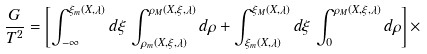<formula> <loc_0><loc_0><loc_500><loc_500>\frac { G } { T ^ { 2 } } = \left [ \int _ { - \infty } ^ { \xi _ { m } ( X , \lambda ) } d \xi \, \int _ { \rho _ { m } ( X , \xi , \lambda ) } ^ { \rho _ { M } ( X , \xi , \lambda ) } d \rho + \int _ { \xi _ { m } ( X , \lambda ) } ^ { \xi _ { M } ( X , \lambda ) } d \xi \, \int _ { 0 } ^ { \rho _ { M } ( X , \xi , \lambda ) } d \rho \right ] \times</formula> 